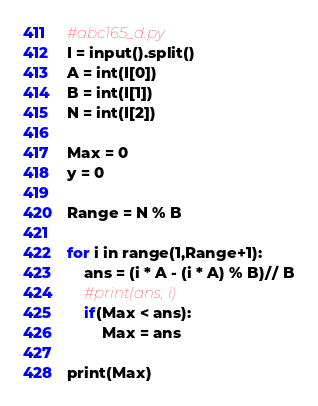Convert code to text. <code><loc_0><loc_0><loc_500><loc_500><_Python_>#abc165_d.py
I = input().split()
A = int(I[0])
B = int(I[1])
N = int(I[2])

Max = 0
y = 0

Range = N % B

for i in range(1,Range+1):
    ans = (i * A - (i * A) % B)// B
    #print(ans, i)
    if(Max < ans):
        Max = ans

print(Max)</code> 